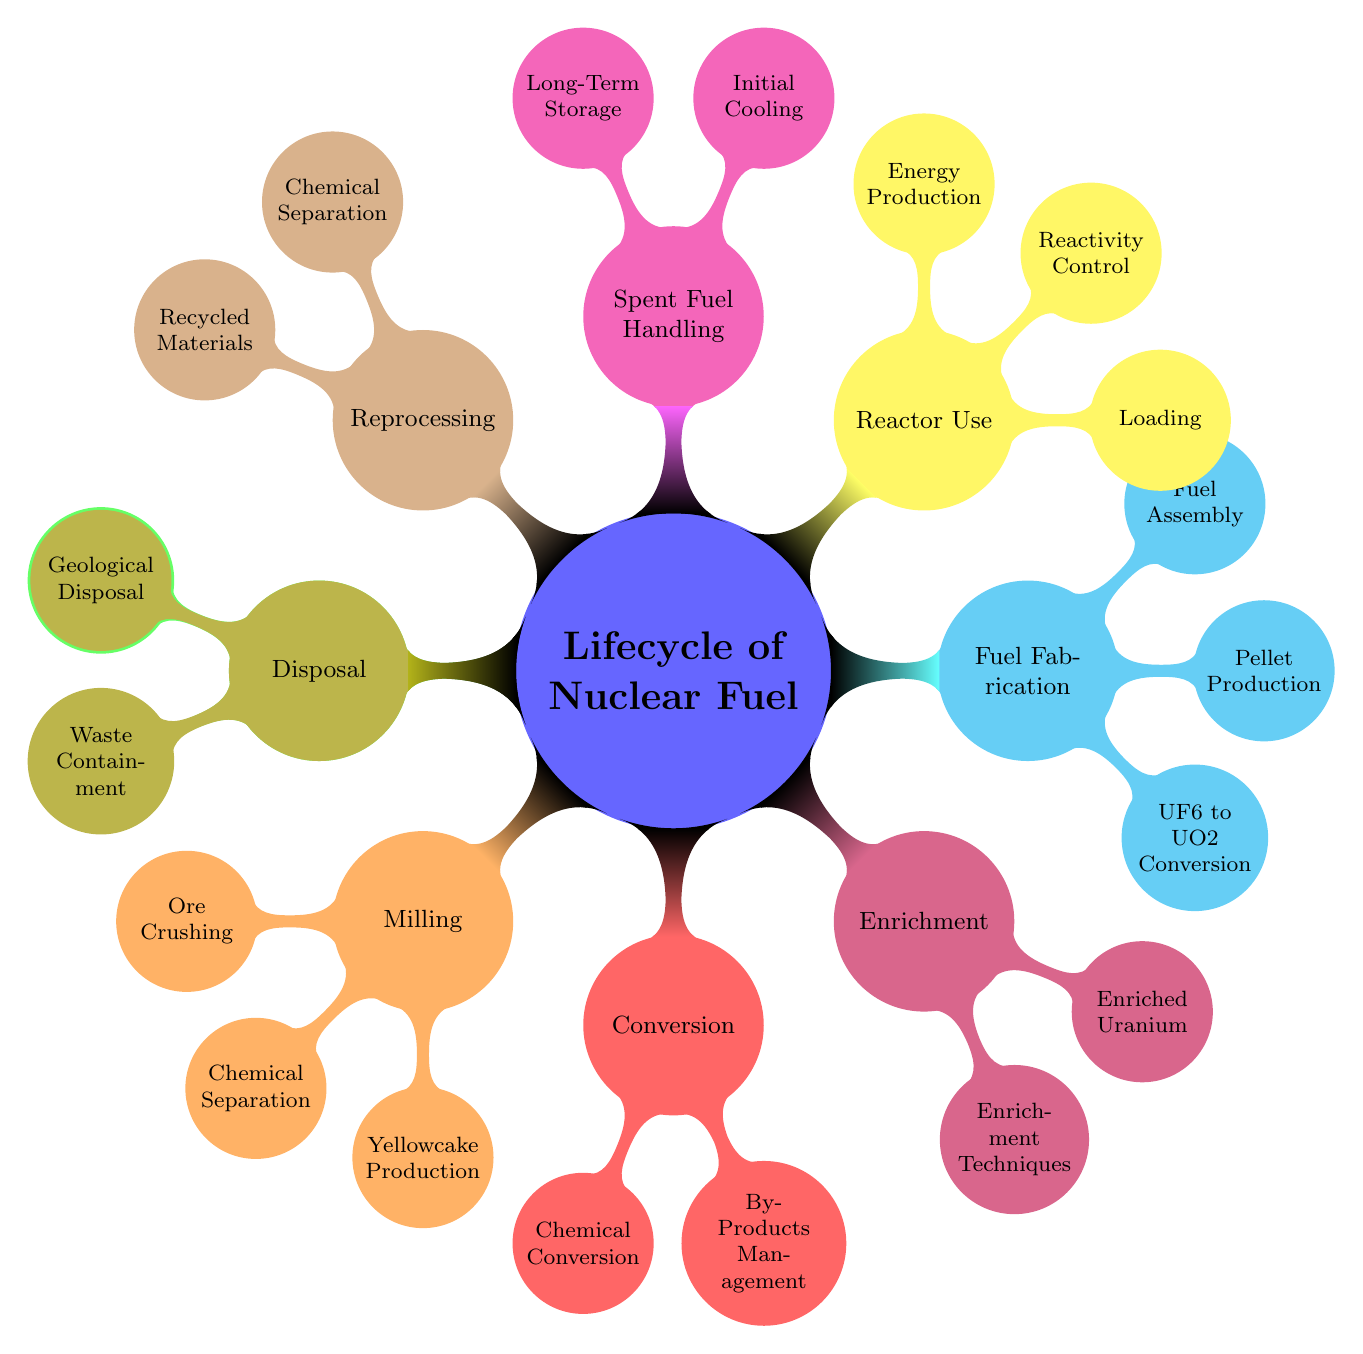What is the first stage in the lifecycle of nuclear fuel? The mind map lists "Mining" as the first child node under the main concept "Lifecycle of Nuclear Fuel." This indicates it is the initial stage in the process.
Answer: Mining How many primary stages are there in the lifecycle of nuclear fuel? By counting the main child nodes connected to "Lifecycle of Nuclear Fuel," there are a total of eight primary stages: Mining, Milling, Conversion, Enrichment, Fuel Fabrication, Reactor Use, Spent Fuel Handling, Reprocessing, and Disposal.
Answer: 8 What is produced during milling? The mind map indicates that "Yellowcake Production" is a child node under "Milling," indicating that yellowcake is a product of this stage in the fuel lifecycle.
Answer: Yellowcake Production Which process is used for uranium extraction? The diagram mentions "Conventional Mining" and "In-Situ Leaching" as methods of uranium extraction under the "Mining" node. Therefore, both methods are relevant answers, but usually, "In-Situ Leaching" is a common contemporary extraction method mentioned specifically.
Answer: In-Situ Leaching What technique is highlighted under reprocessing? The mind map highlights "PUREX Process" as the chemical separation technique used in reprocessing, indicating it is a key method within that stage.
Answer: PUREX Process What is the final stage of nuclear fuel lifecycle? The last child node listed in the mind map under the "Lifecycle of Nuclear Fuel" is "Disposal," which identifies it as the last process in the lifecycle.
Answer: Disposal What is the output material produced from conversion? The "Conversion" phase focuses on producing "UF6" during chemical conversion, making it a critical output of this lifecycle stage.
Answer: UF6 Which component is essential for reactivity control during reactor use? The mind map mentions "Control Rods" as a child node under "Reactivity Control," indicating that this is a crucial component utilized for maintaining and adjusting reactivity in a nuclear reactor.
Answer: Control Rods What type of storage is mentioned for spent fuel handling? The mind map lists both "Spent Fuel Pool" and "Dry Cask Storage" under "Spent Fuel Handling." Therefore, both could be valid answers, though "Dry Cask Storage" represents long-term options typically recognized.
Answer: Dry Cask Storage 